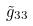<formula> <loc_0><loc_0><loc_500><loc_500>\tilde { g } _ { 3 3 }</formula> 